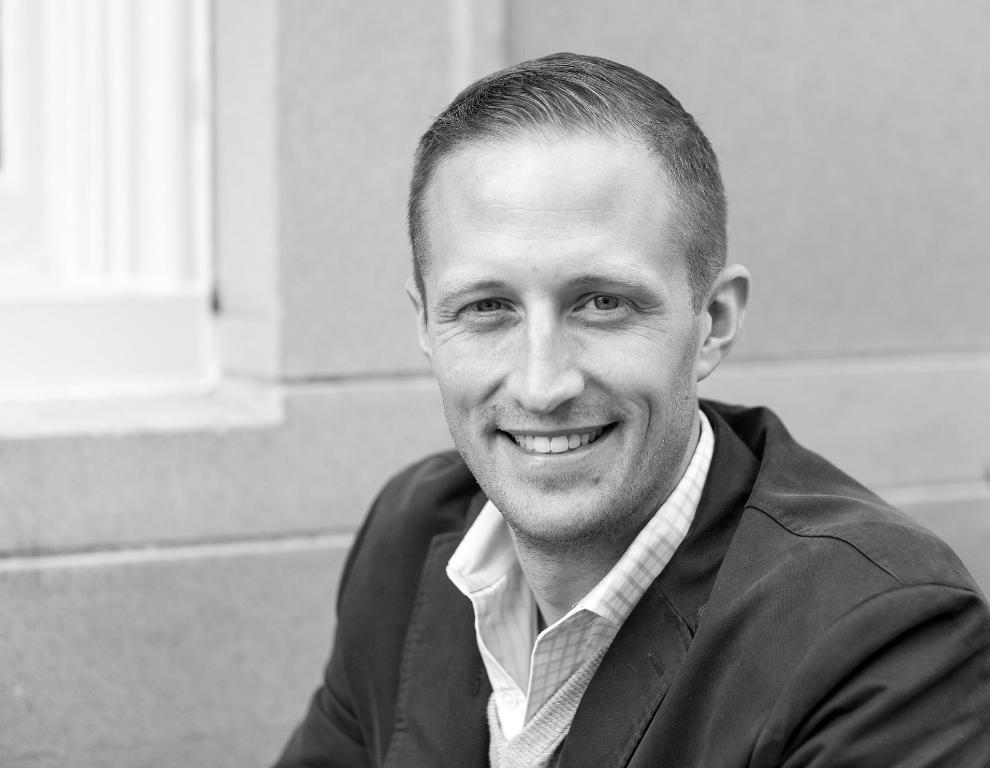What is present in the image? There is a person in the image. What can be seen in the background of the image? There is a wall and a window in the background of the image. How many cards are being held by the person in the image? There is no mention of cards in the image, so it cannot be determined if any are being held. 